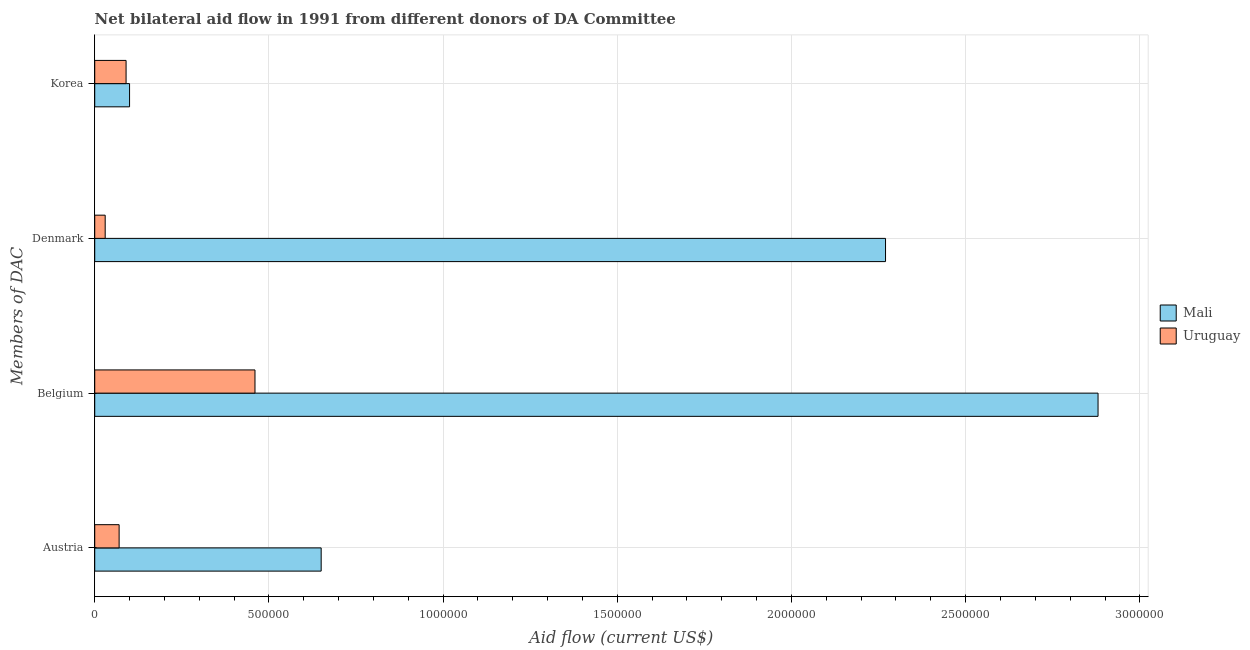How many different coloured bars are there?
Provide a succinct answer. 2. Are the number of bars per tick equal to the number of legend labels?
Give a very brief answer. Yes. Are the number of bars on each tick of the Y-axis equal?
Make the answer very short. Yes. How many bars are there on the 4th tick from the top?
Your response must be concise. 2. What is the amount of aid given by korea in Mali?
Offer a terse response. 1.00e+05. Across all countries, what is the maximum amount of aid given by korea?
Your answer should be very brief. 1.00e+05. Across all countries, what is the minimum amount of aid given by belgium?
Make the answer very short. 4.60e+05. In which country was the amount of aid given by denmark maximum?
Provide a succinct answer. Mali. In which country was the amount of aid given by austria minimum?
Offer a very short reply. Uruguay. What is the total amount of aid given by belgium in the graph?
Keep it short and to the point. 3.34e+06. What is the difference between the amount of aid given by belgium in Mali and that in Uruguay?
Make the answer very short. 2.42e+06. What is the difference between the amount of aid given by korea in Uruguay and the amount of aid given by austria in Mali?
Keep it short and to the point. -5.60e+05. What is the average amount of aid given by belgium per country?
Offer a terse response. 1.67e+06. What is the difference between the amount of aid given by belgium and amount of aid given by austria in Uruguay?
Provide a short and direct response. 3.90e+05. In how many countries, is the amount of aid given by korea greater than 1000000 US$?
Keep it short and to the point. 0. What is the ratio of the amount of aid given by denmark in Mali to that in Uruguay?
Make the answer very short. 75.67. What is the difference between the highest and the second highest amount of aid given by belgium?
Provide a succinct answer. 2.42e+06. What is the difference between the highest and the lowest amount of aid given by denmark?
Offer a terse response. 2.24e+06. In how many countries, is the amount of aid given by denmark greater than the average amount of aid given by denmark taken over all countries?
Your response must be concise. 1. Is the sum of the amount of aid given by denmark in Mali and Uruguay greater than the maximum amount of aid given by korea across all countries?
Offer a terse response. Yes. What does the 1st bar from the top in Austria represents?
Your response must be concise. Uruguay. What does the 2nd bar from the bottom in Korea represents?
Your answer should be very brief. Uruguay. Are all the bars in the graph horizontal?
Offer a very short reply. Yes. What is the difference between two consecutive major ticks on the X-axis?
Provide a succinct answer. 5.00e+05. How many legend labels are there?
Offer a very short reply. 2. How are the legend labels stacked?
Your answer should be very brief. Vertical. What is the title of the graph?
Your response must be concise. Net bilateral aid flow in 1991 from different donors of DA Committee. Does "Lithuania" appear as one of the legend labels in the graph?
Provide a short and direct response. No. What is the label or title of the X-axis?
Provide a short and direct response. Aid flow (current US$). What is the label or title of the Y-axis?
Give a very brief answer. Members of DAC. What is the Aid flow (current US$) of Mali in Austria?
Ensure brevity in your answer.  6.50e+05. What is the Aid flow (current US$) of Uruguay in Austria?
Offer a very short reply. 7.00e+04. What is the Aid flow (current US$) of Mali in Belgium?
Make the answer very short. 2.88e+06. What is the Aid flow (current US$) of Mali in Denmark?
Make the answer very short. 2.27e+06. Across all Members of DAC, what is the maximum Aid flow (current US$) of Mali?
Offer a very short reply. 2.88e+06. What is the total Aid flow (current US$) in Mali in the graph?
Your response must be concise. 5.90e+06. What is the total Aid flow (current US$) of Uruguay in the graph?
Your answer should be compact. 6.50e+05. What is the difference between the Aid flow (current US$) in Mali in Austria and that in Belgium?
Make the answer very short. -2.23e+06. What is the difference between the Aid flow (current US$) in Uruguay in Austria and that in Belgium?
Provide a short and direct response. -3.90e+05. What is the difference between the Aid flow (current US$) of Mali in Austria and that in Denmark?
Your answer should be compact. -1.62e+06. What is the difference between the Aid flow (current US$) in Uruguay in Austria and that in Korea?
Your answer should be very brief. -2.00e+04. What is the difference between the Aid flow (current US$) of Uruguay in Belgium and that in Denmark?
Offer a terse response. 4.30e+05. What is the difference between the Aid flow (current US$) of Mali in Belgium and that in Korea?
Your answer should be compact. 2.78e+06. What is the difference between the Aid flow (current US$) of Mali in Denmark and that in Korea?
Ensure brevity in your answer.  2.17e+06. What is the difference between the Aid flow (current US$) of Mali in Austria and the Aid flow (current US$) of Uruguay in Denmark?
Give a very brief answer. 6.20e+05. What is the difference between the Aid flow (current US$) of Mali in Austria and the Aid flow (current US$) of Uruguay in Korea?
Your response must be concise. 5.60e+05. What is the difference between the Aid flow (current US$) in Mali in Belgium and the Aid flow (current US$) in Uruguay in Denmark?
Your response must be concise. 2.85e+06. What is the difference between the Aid flow (current US$) in Mali in Belgium and the Aid flow (current US$) in Uruguay in Korea?
Your answer should be very brief. 2.79e+06. What is the difference between the Aid flow (current US$) of Mali in Denmark and the Aid flow (current US$) of Uruguay in Korea?
Offer a terse response. 2.18e+06. What is the average Aid flow (current US$) in Mali per Members of DAC?
Your answer should be very brief. 1.48e+06. What is the average Aid flow (current US$) in Uruguay per Members of DAC?
Your answer should be compact. 1.62e+05. What is the difference between the Aid flow (current US$) of Mali and Aid flow (current US$) of Uruguay in Austria?
Provide a short and direct response. 5.80e+05. What is the difference between the Aid flow (current US$) of Mali and Aid flow (current US$) of Uruguay in Belgium?
Your response must be concise. 2.42e+06. What is the difference between the Aid flow (current US$) in Mali and Aid flow (current US$) in Uruguay in Denmark?
Your answer should be compact. 2.24e+06. What is the ratio of the Aid flow (current US$) in Mali in Austria to that in Belgium?
Provide a short and direct response. 0.23. What is the ratio of the Aid flow (current US$) in Uruguay in Austria to that in Belgium?
Provide a succinct answer. 0.15. What is the ratio of the Aid flow (current US$) of Mali in Austria to that in Denmark?
Your response must be concise. 0.29. What is the ratio of the Aid flow (current US$) in Uruguay in Austria to that in Denmark?
Offer a terse response. 2.33. What is the ratio of the Aid flow (current US$) in Uruguay in Austria to that in Korea?
Make the answer very short. 0.78. What is the ratio of the Aid flow (current US$) in Mali in Belgium to that in Denmark?
Ensure brevity in your answer.  1.27. What is the ratio of the Aid flow (current US$) in Uruguay in Belgium to that in Denmark?
Provide a succinct answer. 15.33. What is the ratio of the Aid flow (current US$) of Mali in Belgium to that in Korea?
Provide a short and direct response. 28.8. What is the ratio of the Aid flow (current US$) in Uruguay in Belgium to that in Korea?
Give a very brief answer. 5.11. What is the ratio of the Aid flow (current US$) in Mali in Denmark to that in Korea?
Make the answer very short. 22.7. What is the ratio of the Aid flow (current US$) in Uruguay in Denmark to that in Korea?
Your answer should be very brief. 0.33. What is the difference between the highest and the second highest Aid flow (current US$) of Mali?
Keep it short and to the point. 6.10e+05. What is the difference between the highest and the second highest Aid flow (current US$) in Uruguay?
Keep it short and to the point. 3.70e+05. What is the difference between the highest and the lowest Aid flow (current US$) of Mali?
Offer a very short reply. 2.78e+06. What is the difference between the highest and the lowest Aid flow (current US$) in Uruguay?
Ensure brevity in your answer.  4.30e+05. 